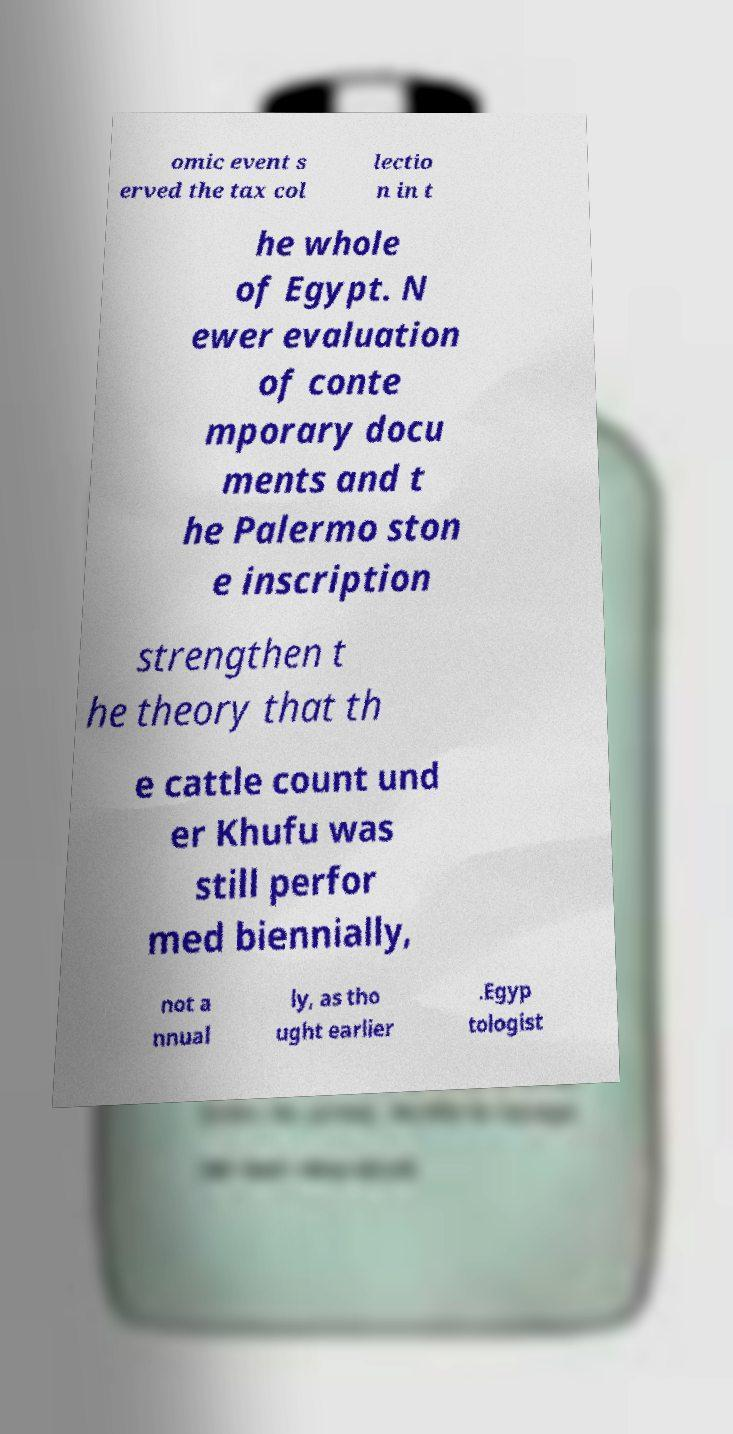Could you assist in decoding the text presented in this image and type it out clearly? omic event s erved the tax col lectio n in t he whole of Egypt. N ewer evaluation of conte mporary docu ments and t he Palermo ston e inscription strengthen t he theory that th e cattle count und er Khufu was still perfor med biennially, not a nnual ly, as tho ught earlier .Egyp tologist 